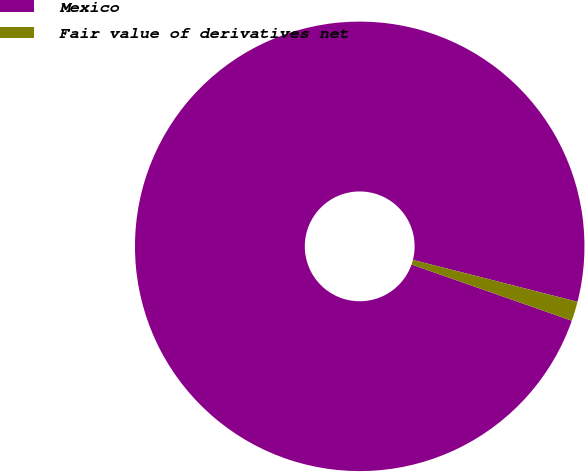Convert chart to OTSL. <chart><loc_0><loc_0><loc_500><loc_500><pie_chart><fcel>Mexico<fcel>Fair value of derivatives net<nl><fcel>98.6%<fcel>1.4%<nl></chart> 